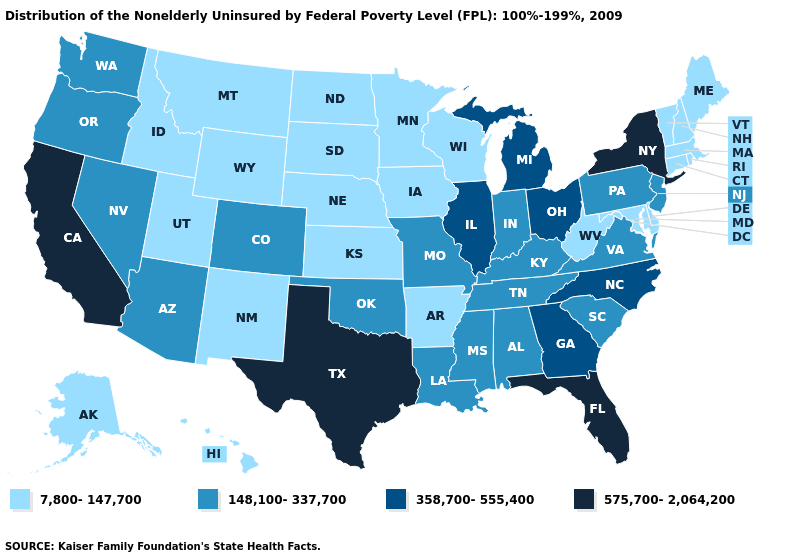Name the states that have a value in the range 148,100-337,700?
Quick response, please. Alabama, Arizona, Colorado, Indiana, Kentucky, Louisiana, Mississippi, Missouri, Nevada, New Jersey, Oklahoma, Oregon, Pennsylvania, South Carolina, Tennessee, Virginia, Washington. Does the first symbol in the legend represent the smallest category?
Short answer required. Yes. Name the states that have a value in the range 358,700-555,400?
Keep it brief. Georgia, Illinois, Michigan, North Carolina, Ohio. Does the map have missing data?
Give a very brief answer. No. What is the lowest value in the USA?
Short answer required. 7,800-147,700. What is the value of Missouri?
Be succinct. 148,100-337,700. Does the map have missing data?
Be succinct. No. What is the value of Montana?
Write a very short answer. 7,800-147,700. What is the highest value in the Northeast ?
Keep it brief. 575,700-2,064,200. Name the states that have a value in the range 148,100-337,700?
Write a very short answer. Alabama, Arizona, Colorado, Indiana, Kentucky, Louisiana, Mississippi, Missouri, Nevada, New Jersey, Oklahoma, Oregon, Pennsylvania, South Carolina, Tennessee, Virginia, Washington. What is the value of Ohio?
Quick response, please. 358,700-555,400. Name the states that have a value in the range 148,100-337,700?
Be succinct. Alabama, Arizona, Colorado, Indiana, Kentucky, Louisiana, Mississippi, Missouri, Nevada, New Jersey, Oklahoma, Oregon, Pennsylvania, South Carolina, Tennessee, Virginia, Washington. Name the states that have a value in the range 358,700-555,400?
Give a very brief answer. Georgia, Illinois, Michigan, North Carolina, Ohio. What is the lowest value in the West?
Keep it brief. 7,800-147,700. Which states have the lowest value in the West?
Write a very short answer. Alaska, Hawaii, Idaho, Montana, New Mexico, Utah, Wyoming. 